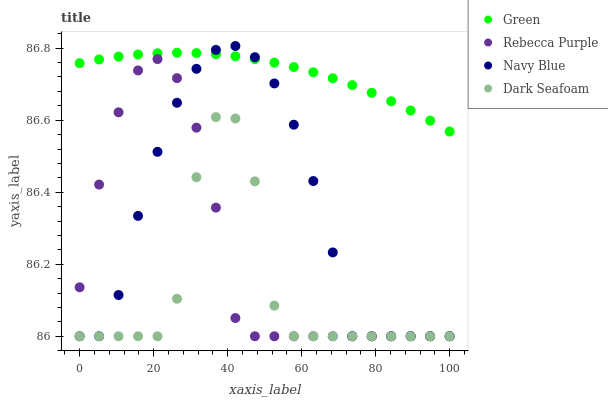Does Dark Seafoam have the minimum area under the curve?
Answer yes or no. Yes. Does Green have the maximum area under the curve?
Answer yes or no. Yes. Does Green have the minimum area under the curve?
Answer yes or no. No. Does Dark Seafoam have the maximum area under the curve?
Answer yes or no. No. Is Green the smoothest?
Answer yes or no. Yes. Is Dark Seafoam the roughest?
Answer yes or no. Yes. Is Dark Seafoam the smoothest?
Answer yes or no. No. Is Green the roughest?
Answer yes or no. No. Does Navy Blue have the lowest value?
Answer yes or no. Yes. Does Green have the lowest value?
Answer yes or no. No. Does Navy Blue have the highest value?
Answer yes or no. Yes. Does Green have the highest value?
Answer yes or no. No. Is Dark Seafoam less than Green?
Answer yes or no. Yes. Is Green greater than Dark Seafoam?
Answer yes or no. Yes. Does Green intersect Navy Blue?
Answer yes or no. Yes. Is Green less than Navy Blue?
Answer yes or no. No. Is Green greater than Navy Blue?
Answer yes or no. No. Does Dark Seafoam intersect Green?
Answer yes or no. No. 